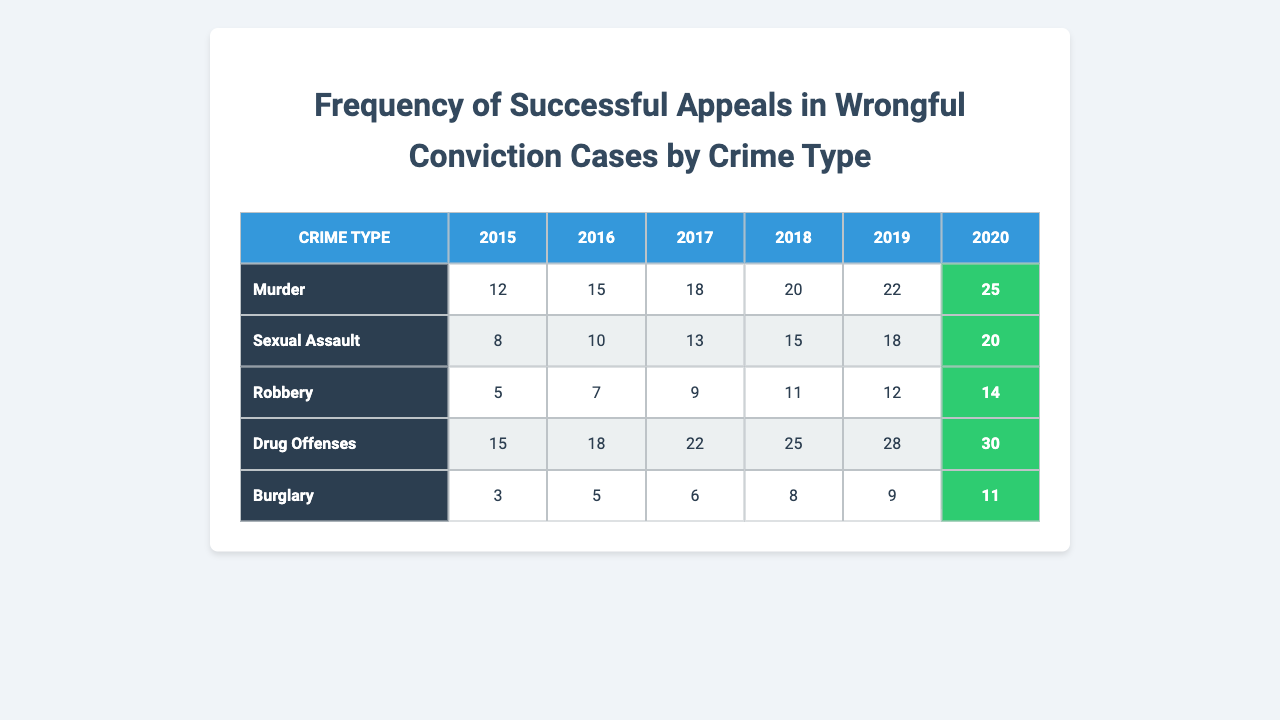What was the year with the highest number of successful appeals for Murder? In the row for Murder, the successful appeals increase each year from 12 in 2015 to 25 in 2020. The highest number is 25 in 2020.
Answer: 2020 How many successful appeals were there for Drug Offenses in 2017? In the row for Drug Offenses, the value for 2017 is 22 successful appeals.
Answer: 22 Which crime type had the lowest total number of successful appeals over the six years? Summing up the successful appeals for each crime type: Murder (112), Sexual Assault (84), Robbery (58), Drug Offenses (138), Burglary (42). Burglary has the lowest total of 42.
Answer: Burglary What is the difference in the number of successful appeals for Sexual Assault between 2018 and 2019? The number for Sexual Assault in 2018 is 15 and in 2019 is 18. The difference is 18 - 15 = 3.
Answer: 3 True or False: The number of successful appeals for Robbery increased every year from 2015 to 2020. The values for Robbery are 5, 7, 9, 11, 12, 14, which show a consistent increase each year.
Answer: True What is the average number of successful appeals for Drug Offenses over the years provided? Add the successful appeals for Drug Offenses: 15 + 18 + 22 + 25 + 28 + 30 = 138. There are 6 years, so the average is 138 / 6 = 23.
Answer: 23 Which crime type had the highest number of successful appeals in 2019, and how many were there? The values for 2019 are: Murder (22), Sexual Assault (18), Robbery (12), Drug Offenses (28), Burglary (9). The highest is 28 for Drug Offenses.
Answer: Drug Offenses, 28 What is the total number of successful appeals for Murder from 2015 to 2019? Summing the successful appeals for Murder: 12 + 15 + 18 + 20 + 22 = 87.
Answer: 87 In 2016, how many more successful appeals were there for Drug Offenses compared to Burglary? The number for Drug Offenses in 2016 is 18, and for Burglary, it is 5. The difference is 18 - 5 = 13.
Answer: 13 What trend can be observed in the number of successful appeals for Sexual Assault over the years? The numbers show a continuous upward trend from 8 in 2015 to 20 in 2020.
Answer: Continuous increase 